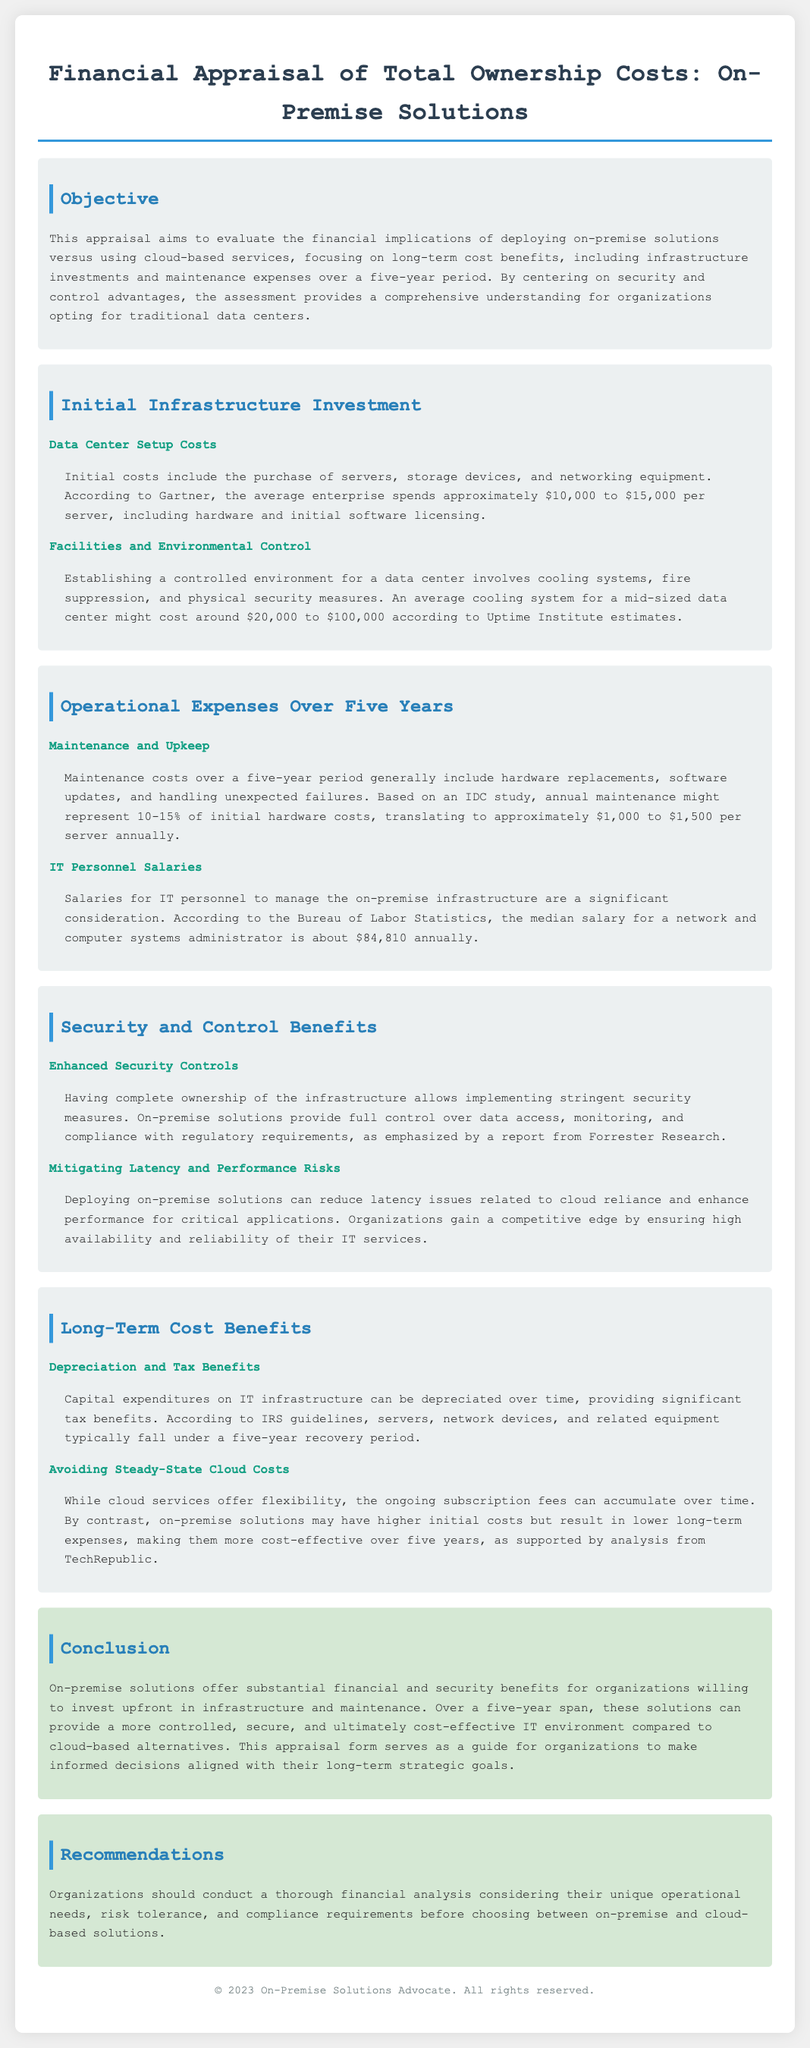What is the objective of the appraisal? The objective is to evaluate the financial implications of deploying on-premise solutions versus cloud-based services, focusing on long-term cost benefits.
Answer: Evaluate financial implications What are initial infrastructure investment costs per server? Initial costs include the purchase of servers, storage devices, and networking equipment, which average around $10,000 to $15,000 per server.
Answer: $10,000 to $15,000 What is the average cooling system cost for a mid-sized data center? The average cooling system cost for a mid-sized data center might range from $20,000 to $100,000.
Answer: $20,000 to $100,000 What percentage of the initial hardware costs does annual maintenance represent? Annual maintenance might represent 10-15% of initial hardware costs.
Answer: 10-15% What is the median annual salary for IT personnel? The median salary for a network and computer systems administrator is about $84,810 annually.
Answer: $84,810 What security advantage do on-premise solutions offer? On-premise solutions provide full control over data access, monitoring, and compliance with regulatory requirements.
Answer: Full control over data access What are the long-term cost benefits of on-premise solutions mentioned? Long-term cost benefits include depreciation and tax benefits, as well as avoiding steady-state cloud costs.
Answer: Depreciation and tax benefits What should organizations do before choosing between solutions? Organizations should conduct a thorough financial analysis considering their unique operational needs, risk tolerance, and compliance requirements.
Answer: Conduct a thorough financial analysis Over a five-year span, which solution is more cost-effective? On-premise solutions may have higher initial costs but result in lower long-term expenses, making them more cost-effective over five years.
Answer: On-premise solutions 